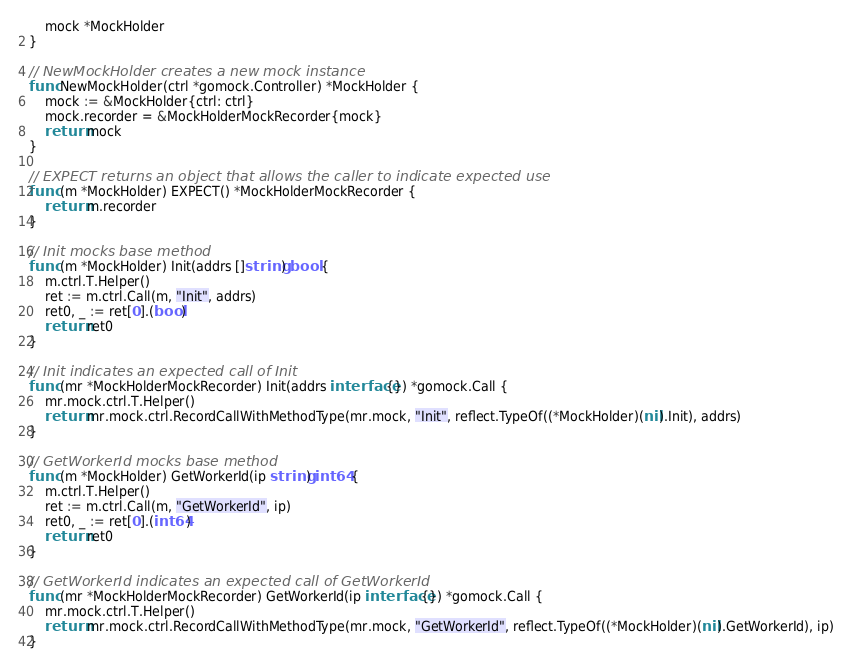Convert code to text. <code><loc_0><loc_0><loc_500><loc_500><_Go_>	mock *MockHolder
}

// NewMockHolder creates a new mock instance
func NewMockHolder(ctrl *gomock.Controller) *MockHolder {
	mock := &MockHolder{ctrl: ctrl}
	mock.recorder = &MockHolderMockRecorder{mock}
	return mock
}

// EXPECT returns an object that allows the caller to indicate expected use
func (m *MockHolder) EXPECT() *MockHolderMockRecorder {
	return m.recorder
}

// Init mocks base method
func (m *MockHolder) Init(addrs []string) bool {
	m.ctrl.T.Helper()
	ret := m.ctrl.Call(m, "Init", addrs)
	ret0, _ := ret[0].(bool)
	return ret0
}

// Init indicates an expected call of Init
func (mr *MockHolderMockRecorder) Init(addrs interface{}) *gomock.Call {
	mr.mock.ctrl.T.Helper()
	return mr.mock.ctrl.RecordCallWithMethodType(mr.mock, "Init", reflect.TypeOf((*MockHolder)(nil).Init), addrs)
}

// GetWorkerId mocks base method
func (m *MockHolder) GetWorkerId(ip string) int64 {
	m.ctrl.T.Helper()
	ret := m.ctrl.Call(m, "GetWorkerId", ip)
	ret0, _ := ret[0].(int64)
	return ret0
}

// GetWorkerId indicates an expected call of GetWorkerId
func (mr *MockHolderMockRecorder) GetWorkerId(ip interface{}) *gomock.Call {
	mr.mock.ctrl.T.Helper()
	return mr.mock.ctrl.RecordCallWithMethodType(mr.mock, "GetWorkerId", reflect.TypeOf((*MockHolder)(nil).GetWorkerId), ip)
}
</code> 